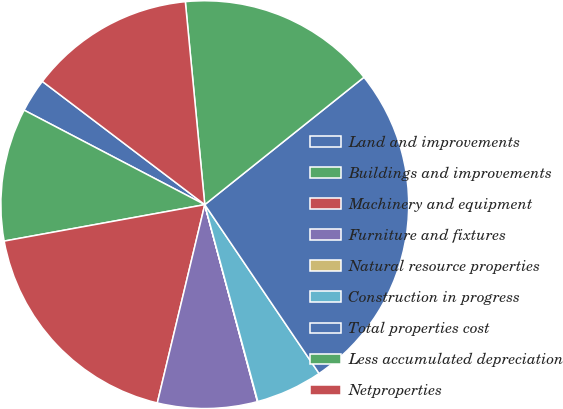Convert chart to OTSL. <chart><loc_0><loc_0><loc_500><loc_500><pie_chart><fcel>Land and improvements<fcel>Buildings and improvements<fcel>Machinery and equipment<fcel>Furniture and fixtures<fcel>Natural resource properties<fcel>Construction in progress<fcel>Total properties cost<fcel>Less accumulated depreciation<fcel>Netproperties<nl><fcel>2.66%<fcel>10.53%<fcel>18.4%<fcel>7.9%<fcel>0.03%<fcel>5.28%<fcel>26.27%<fcel>15.78%<fcel>13.15%<nl></chart> 